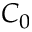Convert formula to latex. <formula><loc_0><loc_0><loc_500><loc_500>C _ { 0 }</formula> 